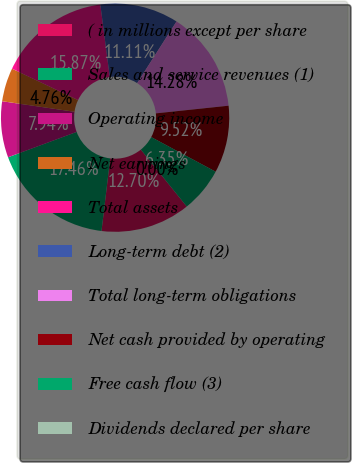<chart> <loc_0><loc_0><loc_500><loc_500><pie_chart><fcel>( in millions except per share<fcel>Sales and service revenues (1)<fcel>Operating income<fcel>Net earnings<fcel>Total assets<fcel>Long-term debt (2)<fcel>Total long-term obligations<fcel>Net cash provided by operating<fcel>Free cash flow (3)<fcel>Dividends declared per share<nl><fcel>12.7%<fcel>17.46%<fcel>7.94%<fcel>4.76%<fcel>15.87%<fcel>11.11%<fcel>14.28%<fcel>9.52%<fcel>6.35%<fcel>0.0%<nl></chart> 